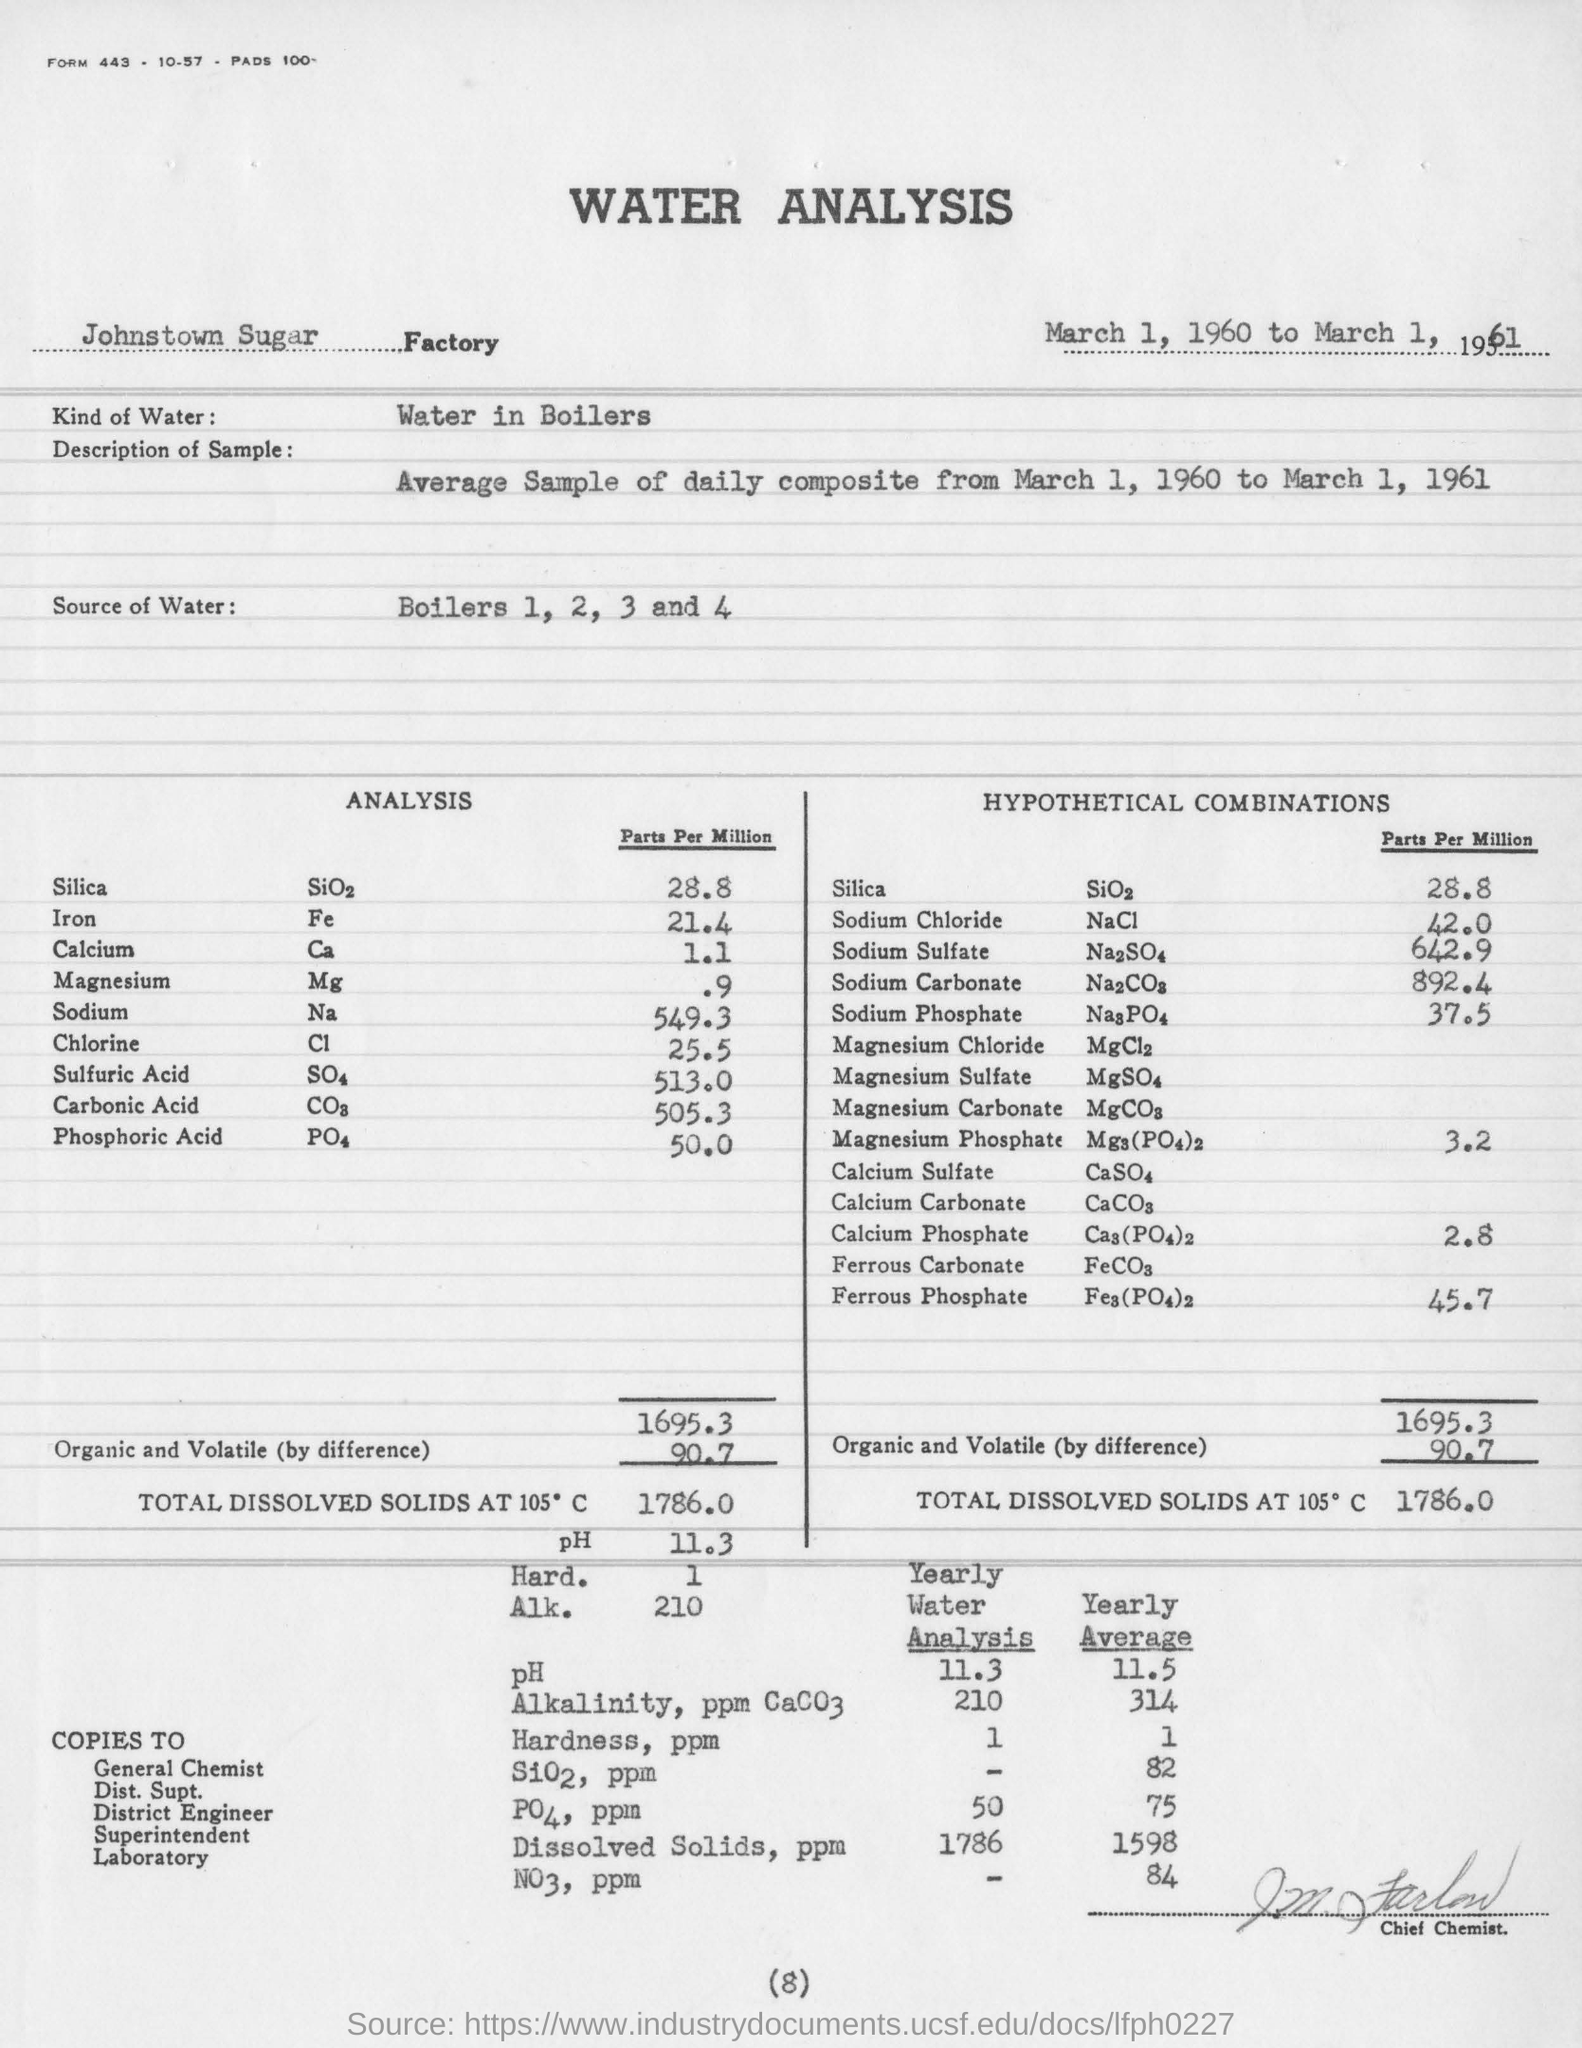In which factory is the analysis conducted?
Offer a very short reply. Johnstown Sugar. What kind of water is used for the analysis?
Provide a succinct answer. Water in Boilers. What is the concentration of Silica in Parts Per Million in the analysis?
Your answer should be compact. 28.8. What is the concentration of Sodium in Parts Per Million in the analysis?
Provide a short and direct response. 549.3. What is the source of water for the analysis?
Offer a very short reply. Boilers 1, 2, 3 and 4. What is the description of the sample?
Give a very brief answer. Average Sample of daily composite from March 1, 1960 to March 1, 1961. 